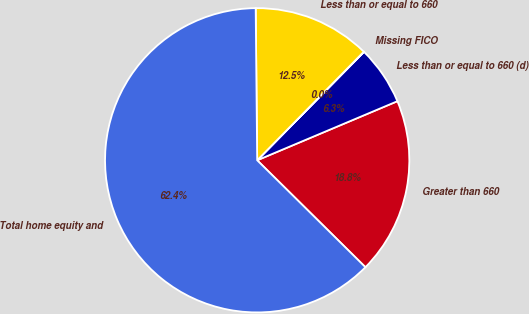Convert chart to OTSL. <chart><loc_0><loc_0><loc_500><loc_500><pie_chart><fcel>Greater than 660<fcel>Less than or equal to 660 (d)<fcel>Missing FICO<fcel>Less than or equal to 660<fcel>Total home equity and<nl><fcel>18.75%<fcel>6.27%<fcel>0.03%<fcel>12.51%<fcel>62.44%<nl></chart> 